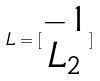Convert formula to latex. <formula><loc_0><loc_0><loc_500><loc_500>L = [ \begin{matrix} - 1 \\ L _ { 2 } \end{matrix} ]</formula> 